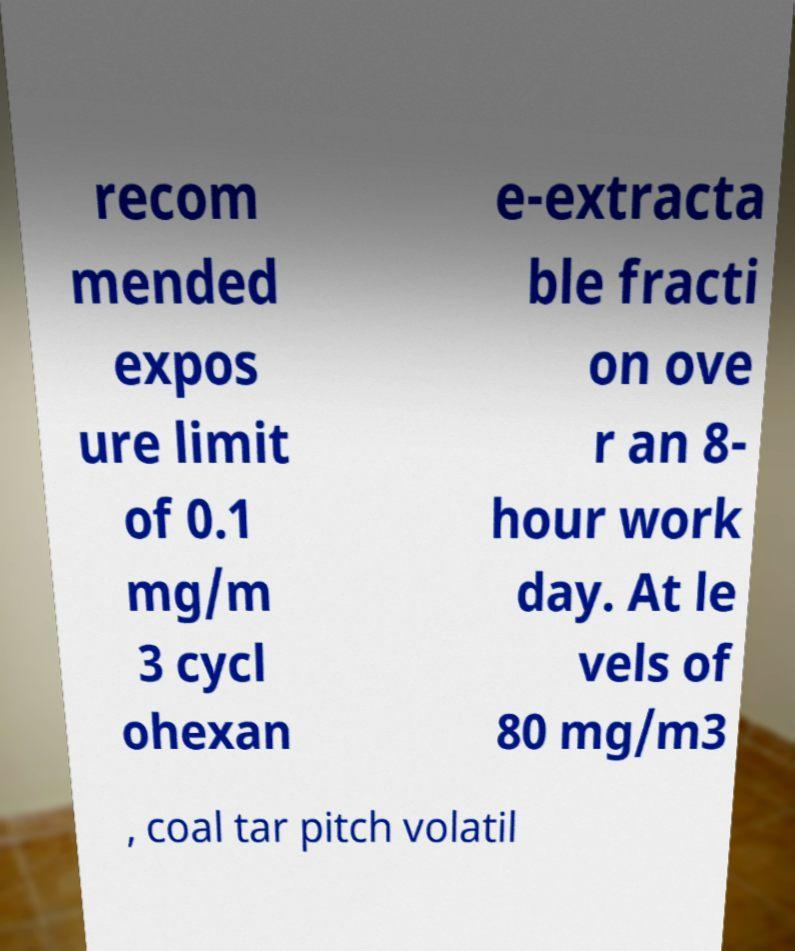Could you extract and type out the text from this image? recom mended expos ure limit of 0.1 mg/m 3 cycl ohexan e-extracta ble fracti on ove r an 8- hour work day. At le vels of 80 mg/m3 , coal tar pitch volatil 